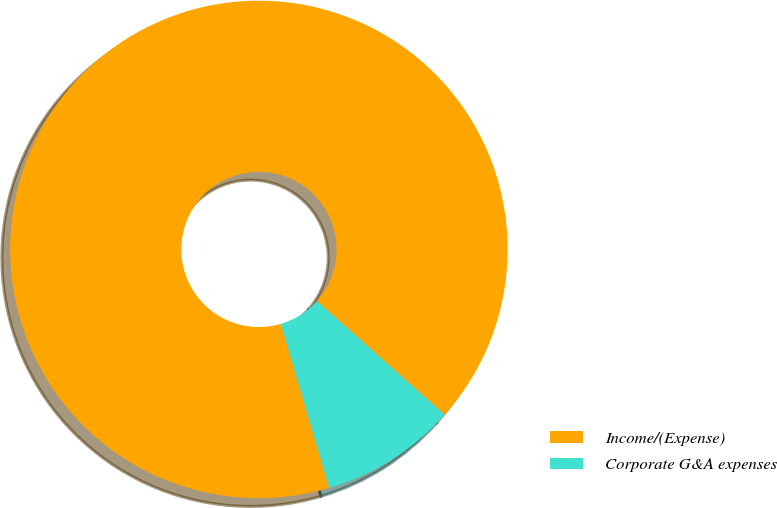<chart> <loc_0><loc_0><loc_500><loc_500><pie_chart><fcel>Income/(Expense)<fcel>Corporate G&A expenses<nl><fcel>91.14%<fcel>8.86%<nl></chart> 